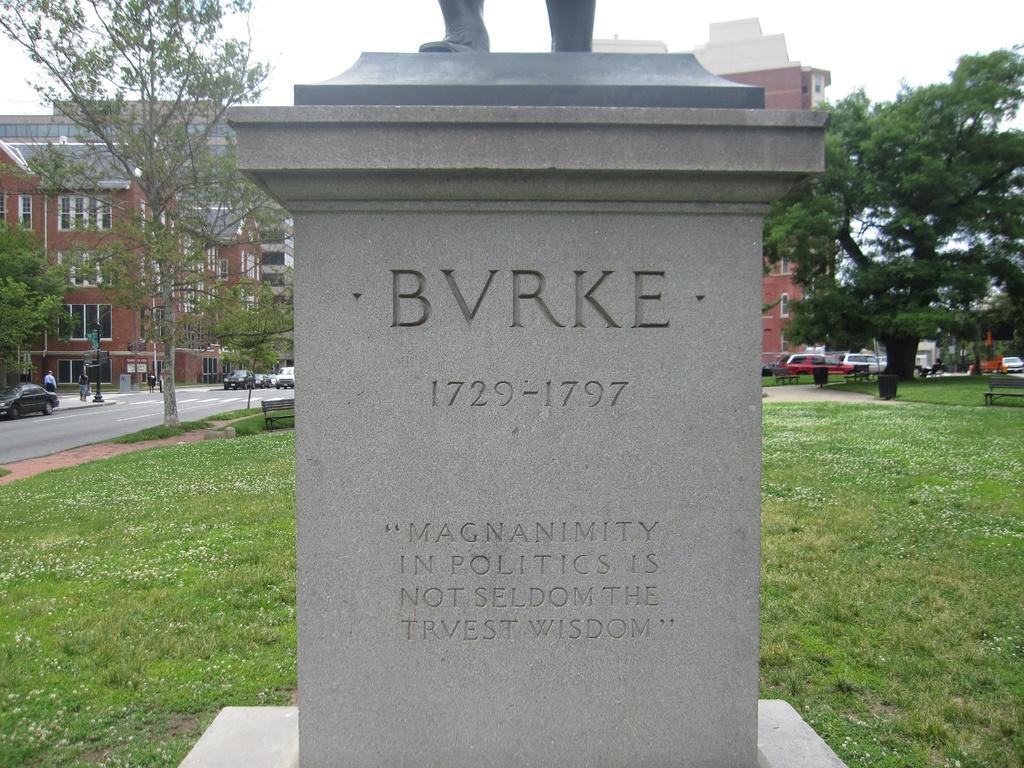Could you give a brief overview of what you see in this image? In this image there is a statue and some text on the block, there are few benches, a bin on the grass, a building, few vehicles and few people on the road, poles and the sky. 